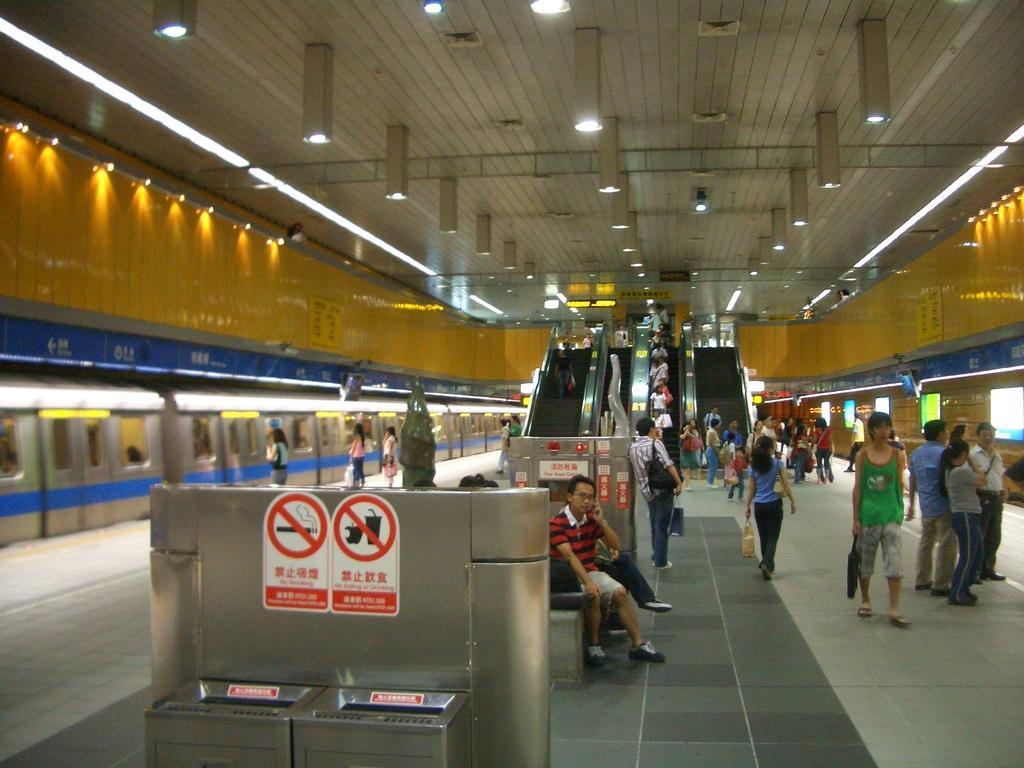In one or two sentences, can you explain what this image depicts? In this image we can see some group of persons standing and walking through the floor and in the background of the image we can see some persons standing on escalator, on left side of the image we can see a train which is on platform and there are some passengers standing near the platform and top of the image there are some lights and roof. 